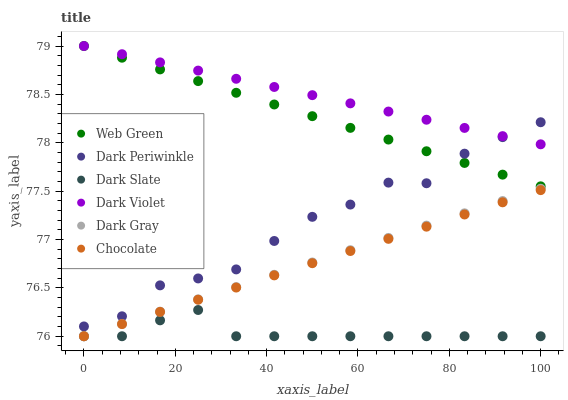Does Dark Slate have the minimum area under the curve?
Answer yes or no. Yes. Does Dark Violet have the maximum area under the curve?
Answer yes or no. Yes. Does Chocolate have the minimum area under the curve?
Answer yes or no. No. Does Chocolate have the maximum area under the curve?
Answer yes or no. No. Is Dark Violet the smoothest?
Answer yes or no. Yes. Is Dark Periwinkle the roughest?
Answer yes or no. Yes. Is Chocolate the smoothest?
Answer yes or no. No. Is Chocolate the roughest?
Answer yes or no. No. Does Chocolate have the lowest value?
Answer yes or no. Yes. Does Web Green have the lowest value?
Answer yes or no. No. Does Web Green have the highest value?
Answer yes or no. Yes. Does Chocolate have the highest value?
Answer yes or no. No. Is Dark Slate less than Dark Violet?
Answer yes or no. Yes. Is Dark Violet greater than Chocolate?
Answer yes or no. Yes. Does Web Green intersect Dark Violet?
Answer yes or no. Yes. Is Web Green less than Dark Violet?
Answer yes or no. No. Is Web Green greater than Dark Violet?
Answer yes or no. No. Does Dark Slate intersect Dark Violet?
Answer yes or no. No. 